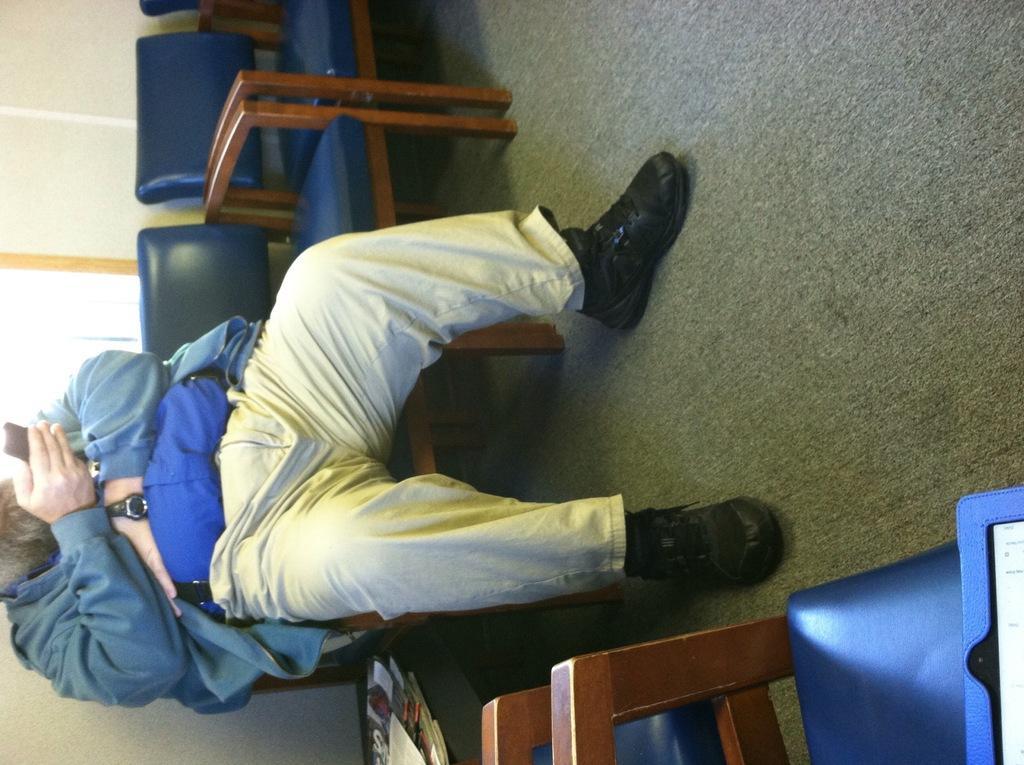Could you give a brief overview of what you see in this image? In the center we can see one person sitting on the chair. And we can see around him few more chairs and he is holding phone. 